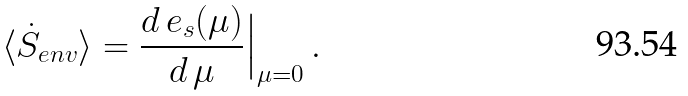<formula> <loc_0><loc_0><loc_500><loc_500>\langle \dot { S } _ { e n v } \rangle = \frac { d \, e _ { s } ( \mu ) } { d \, \mu } \Big | _ { \mu = 0 } \, .</formula> 